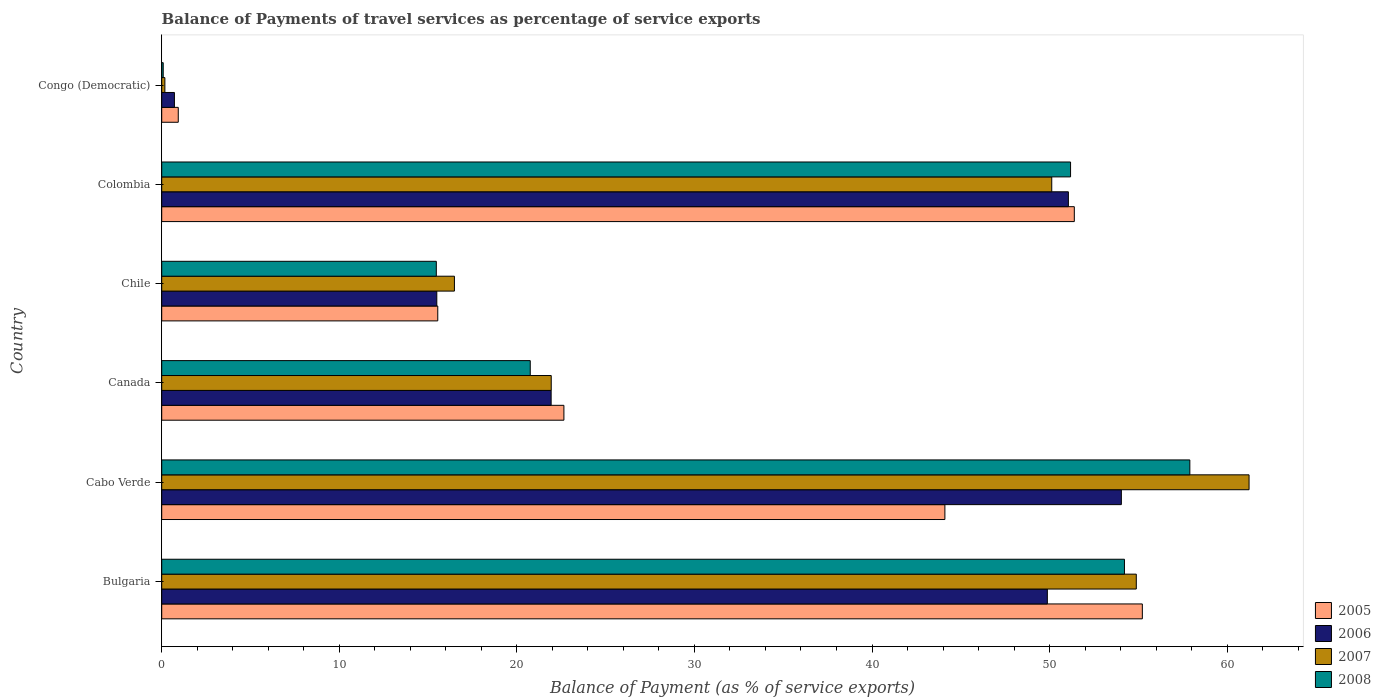Are the number of bars on each tick of the Y-axis equal?
Keep it short and to the point. Yes. How many bars are there on the 5th tick from the top?
Your response must be concise. 4. What is the label of the 4th group of bars from the top?
Ensure brevity in your answer.  Canada. What is the balance of payments of travel services in 2008 in Bulgaria?
Ensure brevity in your answer.  54.22. Across all countries, what is the maximum balance of payments of travel services in 2005?
Give a very brief answer. 55.22. Across all countries, what is the minimum balance of payments of travel services in 2006?
Your response must be concise. 0.72. In which country was the balance of payments of travel services in 2006 maximum?
Your answer should be compact. Cabo Verde. In which country was the balance of payments of travel services in 2007 minimum?
Provide a short and direct response. Congo (Democratic). What is the total balance of payments of travel services in 2008 in the graph?
Give a very brief answer. 199.6. What is the difference between the balance of payments of travel services in 2008 in Bulgaria and that in Cabo Verde?
Your response must be concise. -3.68. What is the difference between the balance of payments of travel services in 2005 in Chile and the balance of payments of travel services in 2007 in Bulgaria?
Your answer should be compact. -39.34. What is the average balance of payments of travel services in 2007 per country?
Provide a succinct answer. 34.14. What is the difference between the balance of payments of travel services in 2005 and balance of payments of travel services in 2008 in Colombia?
Your answer should be very brief. 0.21. What is the ratio of the balance of payments of travel services in 2006 in Canada to that in Colombia?
Ensure brevity in your answer.  0.43. Is the balance of payments of travel services in 2007 in Chile less than that in Congo (Democratic)?
Provide a short and direct response. No. What is the difference between the highest and the second highest balance of payments of travel services in 2007?
Provide a short and direct response. 6.35. What is the difference between the highest and the lowest balance of payments of travel services in 2007?
Provide a short and direct response. 61.05. In how many countries, is the balance of payments of travel services in 2007 greater than the average balance of payments of travel services in 2007 taken over all countries?
Keep it short and to the point. 3. Is the sum of the balance of payments of travel services in 2008 in Cabo Verde and Congo (Democratic) greater than the maximum balance of payments of travel services in 2006 across all countries?
Provide a succinct answer. Yes. What does the 4th bar from the top in Bulgaria represents?
Provide a short and direct response. 2005. What does the 1st bar from the bottom in Cabo Verde represents?
Your answer should be compact. 2005. Are all the bars in the graph horizontal?
Offer a very short reply. Yes. Does the graph contain grids?
Your answer should be compact. No. Where does the legend appear in the graph?
Your answer should be very brief. Bottom right. What is the title of the graph?
Ensure brevity in your answer.  Balance of Payments of travel services as percentage of service exports. What is the label or title of the X-axis?
Keep it short and to the point. Balance of Payment (as % of service exports). What is the label or title of the Y-axis?
Provide a short and direct response. Country. What is the Balance of Payment (as % of service exports) in 2005 in Bulgaria?
Keep it short and to the point. 55.22. What is the Balance of Payment (as % of service exports) in 2006 in Bulgaria?
Ensure brevity in your answer.  49.87. What is the Balance of Payment (as % of service exports) in 2007 in Bulgaria?
Ensure brevity in your answer.  54.88. What is the Balance of Payment (as % of service exports) of 2008 in Bulgaria?
Ensure brevity in your answer.  54.22. What is the Balance of Payment (as % of service exports) of 2005 in Cabo Verde?
Your answer should be very brief. 44.1. What is the Balance of Payment (as % of service exports) in 2006 in Cabo Verde?
Provide a succinct answer. 54.04. What is the Balance of Payment (as % of service exports) of 2007 in Cabo Verde?
Your response must be concise. 61.23. What is the Balance of Payment (as % of service exports) in 2008 in Cabo Verde?
Your answer should be compact. 57.9. What is the Balance of Payment (as % of service exports) in 2005 in Canada?
Keep it short and to the point. 22.65. What is the Balance of Payment (as % of service exports) of 2006 in Canada?
Keep it short and to the point. 21.93. What is the Balance of Payment (as % of service exports) in 2007 in Canada?
Keep it short and to the point. 21.94. What is the Balance of Payment (as % of service exports) in 2008 in Canada?
Offer a terse response. 20.75. What is the Balance of Payment (as % of service exports) in 2005 in Chile?
Offer a very short reply. 15.55. What is the Balance of Payment (as % of service exports) in 2006 in Chile?
Provide a succinct answer. 15.49. What is the Balance of Payment (as % of service exports) in 2007 in Chile?
Your answer should be compact. 16.48. What is the Balance of Payment (as % of service exports) in 2008 in Chile?
Keep it short and to the point. 15.46. What is the Balance of Payment (as % of service exports) of 2005 in Colombia?
Make the answer very short. 51.39. What is the Balance of Payment (as % of service exports) in 2006 in Colombia?
Your answer should be compact. 51.06. What is the Balance of Payment (as % of service exports) in 2007 in Colombia?
Your answer should be very brief. 50.12. What is the Balance of Payment (as % of service exports) in 2008 in Colombia?
Give a very brief answer. 51.18. What is the Balance of Payment (as % of service exports) in 2005 in Congo (Democratic)?
Make the answer very short. 0.93. What is the Balance of Payment (as % of service exports) in 2006 in Congo (Democratic)?
Your answer should be compact. 0.72. What is the Balance of Payment (as % of service exports) in 2007 in Congo (Democratic)?
Provide a short and direct response. 0.18. What is the Balance of Payment (as % of service exports) of 2008 in Congo (Democratic)?
Your response must be concise. 0.08. Across all countries, what is the maximum Balance of Payment (as % of service exports) of 2005?
Make the answer very short. 55.22. Across all countries, what is the maximum Balance of Payment (as % of service exports) in 2006?
Offer a very short reply. 54.04. Across all countries, what is the maximum Balance of Payment (as % of service exports) of 2007?
Provide a succinct answer. 61.23. Across all countries, what is the maximum Balance of Payment (as % of service exports) in 2008?
Provide a succinct answer. 57.9. Across all countries, what is the minimum Balance of Payment (as % of service exports) in 2005?
Your answer should be very brief. 0.93. Across all countries, what is the minimum Balance of Payment (as % of service exports) in 2006?
Provide a succinct answer. 0.72. Across all countries, what is the minimum Balance of Payment (as % of service exports) of 2007?
Your response must be concise. 0.18. Across all countries, what is the minimum Balance of Payment (as % of service exports) in 2008?
Make the answer very short. 0.08. What is the total Balance of Payment (as % of service exports) of 2005 in the graph?
Make the answer very short. 189.84. What is the total Balance of Payment (as % of service exports) in 2006 in the graph?
Provide a short and direct response. 193.11. What is the total Balance of Payment (as % of service exports) in 2007 in the graph?
Provide a short and direct response. 204.83. What is the total Balance of Payment (as % of service exports) in 2008 in the graph?
Ensure brevity in your answer.  199.6. What is the difference between the Balance of Payment (as % of service exports) in 2005 in Bulgaria and that in Cabo Verde?
Give a very brief answer. 11.12. What is the difference between the Balance of Payment (as % of service exports) in 2006 in Bulgaria and that in Cabo Verde?
Keep it short and to the point. -4.17. What is the difference between the Balance of Payment (as % of service exports) in 2007 in Bulgaria and that in Cabo Verde?
Provide a succinct answer. -6.35. What is the difference between the Balance of Payment (as % of service exports) of 2008 in Bulgaria and that in Cabo Verde?
Provide a short and direct response. -3.68. What is the difference between the Balance of Payment (as % of service exports) in 2005 in Bulgaria and that in Canada?
Provide a short and direct response. 32.57. What is the difference between the Balance of Payment (as % of service exports) of 2006 in Bulgaria and that in Canada?
Give a very brief answer. 27.94. What is the difference between the Balance of Payment (as % of service exports) of 2007 in Bulgaria and that in Canada?
Keep it short and to the point. 32.95. What is the difference between the Balance of Payment (as % of service exports) of 2008 in Bulgaria and that in Canada?
Offer a terse response. 33.46. What is the difference between the Balance of Payment (as % of service exports) in 2005 in Bulgaria and that in Chile?
Make the answer very short. 39.68. What is the difference between the Balance of Payment (as % of service exports) in 2006 in Bulgaria and that in Chile?
Your answer should be compact. 34.38. What is the difference between the Balance of Payment (as % of service exports) of 2007 in Bulgaria and that in Chile?
Provide a short and direct response. 38.4. What is the difference between the Balance of Payment (as % of service exports) in 2008 in Bulgaria and that in Chile?
Offer a terse response. 38.75. What is the difference between the Balance of Payment (as % of service exports) in 2005 in Bulgaria and that in Colombia?
Your answer should be very brief. 3.83. What is the difference between the Balance of Payment (as % of service exports) in 2006 in Bulgaria and that in Colombia?
Provide a short and direct response. -1.18. What is the difference between the Balance of Payment (as % of service exports) of 2007 in Bulgaria and that in Colombia?
Provide a short and direct response. 4.76. What is the difference between the Balance of Payment (as % of service exports) of 2008 in Bulgaria and that in Colombia?
Your answer should be compact. 3.03. What is the difference between the Balance of Payment (as % of service exports) in 2005 in Bulgaria and that in Congo (Democratic)?
Keep it short and to the point. 54.29. What is the difference between the Balance of Payment (as % of service exports) in 2006 in Bulgaria and that in Congo (Democratic)?
Give a very brief answer. 49.16. What is the difference between the Balance of Payment (as % of service exports) in 2007 in Bulgaria and that in Congo (Democratic)?
Provide a succinct answer. 54.7. What is the difference between the Balance of Payment (as % of service exports) of 2008 in Bulgaria and that in Congo (Democratic)?
Keep it short and to the point. 54.13. What is the difference between the Balance of Payment (as % of service exports) in 2005 in Cabo Verde and that in Canada?
Provide a succinct answer. 21.45. What is the difference between the Balance of Payment (as % of service exports) in 2006 in Cabo Verde and that in Canada?
Your response must be concise. 32.11. What is the difference between the Balance of Payment (as % of service exports) of 2007 in Cabo Verde and that in Canada?
Keep it short and to the point. 39.3. What is the difference between the Balance of Payment (as % of service exports) of 2008 in Cabo Verde and that in Canada?
Your response must be concise. 37.14. What is the difference between the Balance of Payment (as % of service exports) of 2005 in Cabo Verde and that in Chile?
Your response must be concise. 28.56. What is the difference between the Balance of Payment (as % of service exports) in 2006 in Cabo Verde and that in Chile?
Your answer should be compact. 38.55. What is the difference between the Balance of Payment (as % of service exports) of 2007 in Cabo Verde and that in Chile?
Offer a very short reply. 44.75. What is the difference between the Balance of Payment (as % of service exports) of 2008 in Cabo Verde and that in Chile?
Ensure brevity in your answer.  42.43. What is the difference between the Balance of Payment (as % of service exports) of 2005 in Cabo Verde and that in Colombia?
Make the answer very short. -7.29. What is the difference between the Balance of Payment (as % of service exports) in 2006 in Cabo Verde and that in Colombia?
Keep it short and to the point. 2.98. What is the difference between the Balance of Payment (as % of service exports) of 2007 in Cabo Verde and that in Colombia?
Give a very brief answer. 11.11. What is the difference between the Balance of Payment (as % of service exports) in 2008 in Cabo Verde and that in Colombia?
Your answer should be very brief. 6.72. What is the difference between the Balance of Payment (as % of service exports) in 2005 in Cabo Verde and that in Congo (Democratic)?
Your response must be concise. 43.17. What is the difference between the Balance of Payment (as % of service exports) of 2006 in Cabo Verde and that in Congo (Democratic)?
Your answer should be compact. 53.33. What is the difference between the Balance of Payment (as % of service exports) in 2007 in Cabo Verde and that in Congo (Democratic)?
Offer a very short reply. 61.05. What is the difference between the Balance of Payment (as % of service exports) of 2008 in Cabo Verde and that in Congo (Democratic)?
Your answer should be compact. 57.81. What is the difference between the Balance of Payment (as % of service exports) in 2005 in Canada and that in Chile?
Offer a very short reply. 7.1. What is the difference between the Balance of Payment (as % of service exports) in 2006 in Canada and that in Chile?
Keep it short and to the point. 6.44. What is the difference between the Balance of Payment (as % of service exports) in 2007 in Canada and that in Chile?
Provide a succinct answer. 5.45. What is the difference between the Balance of Payment (as % of service exports) of 2008 in Canada and that in Chile?
Make the answer very short. 5.29. What is the difference between the Balance of Payment (as % of service exports) in 2005 in Canada and that in Colombia?
Offer a terse response. -28.74. What is the difference between the Balance of Payment (as % of service exports) in 2006 in Canada and that in Colombia?
Keep it short and to the point. -29.13. What is the difference between the Balance of Payment (as % of service exports) in 2007 in Canada and that in Colombia?
Provide a succinct answer. -28.19. What is the difference between the Balance of Payment (as % of service exports) of 2008 in Canada and that in Colombia?
Provide a short and direct response. -30.43. What is the difference between the Balance of Payment (as % of service exports) of 2005 in Canada and that in Congo (Democratic)?
Provide a short and direct response. 21.72. What is the difference between the Balance of Payment (as % of service exports) in 2006 in Canada and that in Congo (Democratic)?
Make the answer very short. 21.21. What is the difference between the Balance of Payment (as % of service exports) of 2007 in Canada and that in Congo (Democratic)?
Make the answer very short. 21.76. What is the difference between the Balance of Payment (as % of service exports) of 2008 in Canada and that in Congo (Democratic)?
Give a very brief answer. 20.67. What is the difference between the Balance of Payment (as % of service exports) of 2005 in Chile and that in Colombia?
Provide a succinct answer. -35.85. What is the difference between the Balance of Payment (as % of service exports) of 2006 in Chile and that in Colombia?
Ensure brevity in your answer.  -35.57. What is the difference between the Balance of Payment (as % of service exports) in 2007 in Chile and that in Colombia?
Keep it short and to the point. -33.64. What is the difference between the Balance of Payment (as % of service exports) of 2008 in Chile and that in Colombia?
Ensure brevity in your answer.  -35.72. What is the difference between the Balance of Payment (as % of service exports) in 2005 in Chile and that in Congo (Democratic)?
Offer a very short reply. 14.61. What is the difference between the Balance of Payment (as % of service exports) of 2006 in Chile and that in Congo (Democratic)?
Provide a succinct answer. 14.78. What is the difference between the Balance of Payment (as % of service exports) in 2007 in Chile and that in Congo (Democratic)?
Provide a succinct answer. 16.31. What is the difference between the Balance of Payment (as % of service exports) in 2008 in Chile and that in Congo (Democratic)?
Ensure brevity in your answer.  15.38. What is the difference between the Balance of Payment (as % of service exports) of 2005 in Colombia and that in Congo (Democratic)?
Give a very brief answer. 50.46. What is the difference between the Balance of Payment (as % of service exports) of 2006 in Colombia and that in Congo (Democratic)?
Provide a succinct answer. 50.34. What is the difference between the Balance of Payment (as % of service exports) in 2007 in Colombia and that in Congo (Democratic)?
Your answer should be very brief. 49.94. What is the difference between the Balance of Payment (as % of service exports) of 2008 in Colombia and that in Congo (Democratic)?
Keep it short and to the point. 51.1. What is the difference between the Balance of Payment (as % of service exports) of 2005 in Bulgaria and the Balance of Payment (as % of service exports) of 2006 in Cabo Verde?
Your response must be concise. 1.18. What is the difference between the Balance of Payment (as % of service exports) of 2005 in Bulgaria and the Balance of Payment (as % of service exports) of 2007 in Cabo Verde?
Offer a very short reply. -6.01. What is the difference between the Balance of Payment (as % of service exports) in 2005 in Bulgaria and the Balance of Payment (as % of service exports) in 2008 in Cabo Verde?
Keep it short and to the point. -2.67. What is the difference between the Balance of Payment (as % of service exports) in 2006 in Bulgaria and the Balance of Payment (as % of service exports) in 2007 in Cabo Verde?
Provide a succinct answer. -11.36. What is the difference between the Balance of Payment (as % of service exports) in 2006 in Bulgaria and the Balance of Payment (as % of service exports) in 2008 in Cabo Verde?
Provide a succinct answer. -8.02. What is the difference between the Balance of Payment (as % of service exports) in 2007 in Bulgaria and the Balance of Payment (as % of service exports) in 2008 in Cabo Verde?
Offer a terse response. -3.02. What is the difference between the Balance of Payment (as % of service exports) in 2005 in Bulgaria and the Balance of Payment (as % of service exports) in 2006 in Canada?
Your response must be concise. 33.29. What is the difference between the Balance of Payment (as % of service exports) in 2005 in Bulgaria and the Balance of Payment (as % of service exports) in 2007 in Canada?
Provide a short and direct response. 33.29. What is the difference between the Balance of Payment (as % of service exports) in 2005 in Bulgaria and the Balance of Payment (as % of service exports) in 2008 in Canada?
Give a very brief answer. 34.47. What is the difference between the Balance of Payment (as % of service exports) of 2006 in Bulgaria and the Balance of Payment (as % of service exports) of 2007 in Canada?
Your response must be concise. 27.94. What is the difference between the Balance of Payment (as % of service exports) of 2006 in Bulgaria and the Balance of Payment (as % of service exports) of 2008 in Canada?
Offer a very short reply. 29.12. What is the difference between the Balance of Payment (as % of service exports) in 2007 in Bulgaria and the Balance of Payment (as % of service exports) in 2008 in Canada?
Provide a short and direct response. 34.13. What is the difference between the Balance of Payment (as % of service exports) of 2005 in Bulgaria and the Balance of Payment (as % of service exports) of 2006 in Chile?
Make the answer very short. 39.73. What is the difference between the Balance of Payment (as % of service exports) in 2005 in Bulgaria and the Balance of Payment (as % of service exports) in 2007 in Chile?
Ensure brevity in your answer.  38.74. What is the difference between the Balance of Payment (as % of service exports) in 2005 in Bulgaria and the Balance of Payment (as % of service exports) in 2008 in Chile?
Your response must be concise. 39.76. What is the difference between the Balance of Payment (as % of service exports) in 2006 in Bulgaria and the Balance of Payment (as % of service exports) in 2007 in Chile?
Ensure brevity in your answer.  33.39. What is the difference between the Balance of Payment (as % of service exports) in 2006 in Bulgaria and the Balance of Payment (as % of service exports) in 2008 in Chile?
Give a very brief answer. 34.41. What is the difference between the Balance of Payment (as % of service exports) in 2007 in Bulgaria and the Balance of Payment (as % of service exports) in 2008 in Chile?
Keep it short and to the point. 39.42. What is the difference between the Balance of Payment (as % of service exports) of 2005 in Bulgaria and the Balance of Payment (as % of service exports) of 2006 in Colombia?
Your answer should be compact. 4.17. What is the difference between the Balance of Payment (as % of service exports) of 2005 in Bulgaria and the Balance of Payment (as % of service exports) of 2007 in Colombia?
Offer a very short reply. 5.1. What is the difference between the Balance of Payment (as % of service exports) in 2005 in Bulgaria and the Balance of Payment (as % of service exports) in 2008 in Colombia?
Keep it short and to the point. 4.04. What is the difference between the Balance of Payment (as % of service exports) of 2006 in Bulgaria and the Balance of Payment (as % of service exports) of 2007 in Colombia?
Offer a very short reply. -0.25. What is the difference between the Balance of Payment (as % of service exports) in 2006 in Bulgaria and the Balance of Payment (as % of service exports) in 2008 in Colombia?
Your answer should be very brief. -1.31. What is the difference between the Balance of Payment (as % of service exports) in 2007 in Bulgaria and the Balance of Payment (as % of service exports) in 2008 in Colombia?
Keep it short and to the point. 3.7. What is the difference between the Balance of Payment (as % of service exports) in 2005 in Bulgaria and the Balance of Payment (as % of service exports) in 2006 in Congo (Democratic)?
Provide a short and direct response. 54.51. What is the difference between the Balance of Payment (as % of service exports) of 2005 in Bulgaria and the Balance of Payment (as % of service exports) of 2007 in Congo (Democratic)?
Your answer should be very brief. 55.05. What is the difference between the Balance of Payment (as % of service exports) of 2005 in Bulgaria and the Balance of Payment (as % of service exports) of 2008 in Congo (Democratic)?
Your response must be concise. 55.14. What is the difference between the Balance of Payment (as % of service exports) of 2006 in Bulgaria and the Balance of Payment (as % of service exports) of 2007 in Congo (Democratic)?
Ensure brevity in your answer.  49.7. What is the difference between the Balance of Payment (as % of service exports) in 2006 in Bulgaria and the Balance of Payment (as % of service exports) in 2008 in Congo (Democratic)?
Your answer should be compact. 49.79. What is the difference between the Balance of Payment (as % of service exports) in 2007 in Bulgaria and the Balance of Payment (as % of service exports) in 2008 in Congo (Democratic)?
Make the answer very short. 54.8. What is the difference between the Balance of Payment (as % of service exports) of 2005 in Cabo Verde and the Balance of Payment (as % of service exports) of 2006 in Canada?
Your answer should be very brief. 22.17. What is the difference between the Balance of Payment (as % of service exports) of 2005 in Cabo Verde and the Balance of Payment (as % of service exports) of 2007 in Canada?
Your response must be concise. 22.17. What is the difference between the Balance of Payment (as % of service exports) in 2005 in Cabo Verde and the Balance of Payment (as % of service exports) in 2008 in Canada?
Offer a very short reply. 23.35. What is the difference between the Balance of Payment (as % of service exports) of 2006 in Cabo Verde and the Balance of Payment (as % of service exports) of 2007 in Canada?
Your answer should be very brief. 32.11. What is the difference between the Balance of Payment (as % of service exports) in 2006 in Cabo Verde and the Balance of Payment (as % of service exports) in 2008 in Canada?
Provide a succinct answer. 33.29. What is the difference between the Balance of Payment (as % of service exports) of 2007 in Cabo Verde and the Balance of Payment (as % of service exports) of 2008 in Canada?
Your answer should be compact. 40.48. What is the difference between the Balance of Payment (as % of service exports) in 2005 in Cabo Verde and the Balance of Payment (as % of service exports) in 2006 in Chile?
Offer a terse response. 28.61. What is the difference between the Balance of Payment (as % of service exports) of 2005 in Cabo Verde and the Balance of Payment (as % of service exports) of 2007 in Chile?
Your answer should be very brief. 27.62. What is the difference between the Balance of Payment (as % of service exports) in 2005 in Cabo Verde and the Balance of Payment (as % of service exports) in 2008 in Chile?
Give a very brief answer. 28.64. What is the difference between the Balance of Payment (as % of service exports) of 2006 in Cabo Verde and the Balance of Payment (as % of service exports) of 2007 in Chile?
Make the answer very short. 37.56. What is the difference between the Balance of Payment (as % of service exports) in 2006 in Cabo Verde and the Balance of Payment (as % of service exports) in 2008 in Chile?
Keep it short and to the point. 38.58. What is the difference between the Balance of Payment (as % of service exports) in 2007 in Cabo Verde and the Balance of Payment (as % of service exports) in 2008 in Chile?
Provide a succinct answer. 45.77. What is the difference between the Balance of Payment (as % of service exports) in 2005 in Cabo Verde and the Balance of Payment (as % of service exports) in 2006 in Colombia?
Make the answer very short. -6.95. What is the difference between the Balance of Payment (as % of service exports) of 2005 in Cabo Verde and the Balance of Payment (as % of service exports) of 2007 in Colombia?
Ensure brevity in your answer.  -6.02. What is the difference between the Balance of Payment (as % of service exports) in 2005 in Cabo Verde and the Balance of Payment (as % of service exports) in 2008 in Colombia?
Keep it short and to the point. -7.08. What is the difference between the Balance of Payment (as % of service exports) in 2006 in Cabo Verde and the Balance of Payment (as % of service exports) in 2007 in Colombia?
Your answer should be very brief. 3.92. What is the difference between the Balance of Payment (as % of service exports) in 2006 in Cabo Verde and the Balance of Payment (as % of service exports) in 2008 in Colombia?
Keep it short and to the point. 2.86. What is the difference between the Balance of Payment (as % of service exports) in 2007 in Cabo Verde and the Balance of Payment (as % of service exports) in 2008 in Colombia?
Provide a succinct answer. 10.05. What is the difference between the Balance of Payment (as % of service exports) in 2005 in Cabo Verde and the Balance of Payment (as % of service exports) in 2006 in Congo (Democratic)?
Provide a short and direct response. 43.39. What is the difference between the Balance of Payment (as % of service exports) of 2005 in Cabo Verde and the Balance of Payment (as % of service exports) of 2007 in Congo (Democratic)?
Your answer should be very brief. 43.92. What is the difference between the Balance of Payment (as % of service exports) of 2005 in Cabo Verde and the Balance of Payment (as % of service exports) of 2008 in Congo (Democratic)?
Your answer should be compact. 44.02. What is the difference between the Balance of Payment (as % of service exports) in 2006 in Cabo Verde and the Balance of Payment (as % of service exports) in 2007 in Congo (Democratic)?
Keep it short and to the point. 53.86. What is the difference between the Balance of Payment (as % of service exports) in 2006 in Cabo Verde and the Balance of Payment (as % of service exports) in 2008 in Congo (Democratic)?
Provide a succinct answer. 53.96. What is the difference between the Balance of Payment (as % of service exports) in 2007 in Cabo Verde and the Balance of Payment (as % of service exports) in 2008 in Congo (Democratic)?
Provide a short and direct response. 61.15. What is the difference between the Balance of Payment (as % of service exports) of 2005 in Canada and the Balance of Payment (as % of service exports) of 2006 in Chile?
Your response must be concise. 7.16. What is the difference between the Balance of Payment (as % of service exports) in 2005 in Canada and the Balance of Payment (as % of service exports) in 2007 in Chile?
Make the answer very short. 6.16. What is the difference between the Balance of Payment (as % of service exports) of 2005 in Canada and the Balance of Payment (as % of service exports) of 2008 in Chile?
Provide a succinct answer. 7.19. What is the difference between the Balance of Payment (as % of service exports) of 2006 in Canada and the Balance of Payment (as % of service exports) of 2007 in Chile?
Provide a succinct answer. 5.45. What is the difference between the Balance of Payment (as % of service exports) in 2006 in Canada and the Balance of Payment (as % of service exports) in 2008 in Chile?
Make the answer very short. 6.47. What is the difference between the Balance of Payment (as % of service exports) in 2007 in Canada and the Balance of Payment (as % of service exports) in 2008 in Chile?
Make the answer very short. 6.47. What is the difference between the Balance of Payment (as % of service exports) of 2005 in Canada and the Balance of Payment (as % of service exports) of 2006 in Colombia?
Your answer should be very brief. -28.41. What is the difference between the Balance of Payment (as % of service exports) of 2005 in Canada and the Balance of Payment (as % of service exports) of 2007 in Colombia?
Provide a short and direct response. -27.47. What is the difference between the Balance of Payment (as % of service exports) of 2005 in Canada and the Balance of Payment (as % of service exports) of 2008 in Colombia?
Offer a very short reply. -28.53. What is the difference between the Balance of Payment (as % of service exports) in 2006 in Canada and the Balance of Payment (as % of service exports) in 2007 in Colombia?
Keep it short and to the point. -28.19. What is the difference between the Balance of Payment (as % of service exports) of 2006 in Canada and the Balance of Payment (as % of service exports) of 2008 in Colombia?
Your answer should be very brief. -29.25. What is the difference between the Balance of Payment (as % of service exports) of 2007 in Canada and the Balance of Payment (as % of service exports) of 2008 in Colombia?
Make the answer very short. -29.25. What is the difference between the Balance of Payment (as % of service exports) of 2005 in Canada and the Balance of Payment (as % of service exports) of 2006 in Congo (Democratic)?
Offer a terse response. 21.93. What is the difference between the Balance of Payment (as % of service exports) in 2005 in Canada and the Balance of Payment (as % of service exports) in 2007 in Congo (Democratic)?
Offer a terse response. 22.47. What is the difference between the Balance of Payment (as % of service exports) of 2005 in Canada and the Balance of Payment (as % of service exports) of 2008 in Congo (Democratic)?
Offer a very short reply. 22.56. What is the difference between the Balance of Payment (as % of service exports) of 2006 in Canada and the Balance of Payment (as % of service exports) of 2007 in Congo (Democratic)?
Offer a terse response. 21.75. What is the difference between the Balance of Payment (as % of service exports) of 2006 in Canada and the Balance of Payment (as % of service exports) of 2008 in Congo (Democratic)?
Offer a terse response. 21.85. What is the difference between the Balance of Payment (as % of service exports) in 2007 in Canada and the Balance of Payment (as % of service exports) in 2008 in Congo (Democratic)?
Your response must be concise. 21.85. What is the difference between the Balance of Payment (as % of service exports) of 2005 in Chile and the Balance of Payment (as % of service exports) of 2006 in Colombia?
Give a very brief answer. -35.51. What is the difference between the Balance of Payment (as % of service exports) of 2005 in Chile and the Balance of Payment (as % of service exports) of 2007 in Colombia?
Provide a succinct answer. -34.58. What is the difference between the Balance of Payment (as % of service exports) in 2005 in Chile and the Balance of Payment (as % of service exports) in 2008 in Colombia?
Your answer should be compact. -35.64. What is the difference between the Balance of Payment (as % of service exports) of 2006 in Chile and the Balance of Payment (as % of service exports) of 2007 in Colombia?
Offer a very short reply. -34.63. What is the difference between the Balance of Payment (as % of service exports) of 2006 in Chile and the Balance of Payment (as % of service exports) of 2008 in Colombia?
Give a very brief answer. -35.69. What is the difference between the Balance of Payment (as % of service exports) in 2007 in Chile and the Balance of Payment (as % of service exports) in 2008 in Colombia?
Provide a succinct answer. -34.7. What is the difference between the Balance of Payment (as % of service exports) in 2005 in Chile and the Balance of Payment (as % of service exports) in 2006 in Congo (Democratic)?
Your response must be concise. 14.83. What is the difference between the Balance of Payment (as % of service exports) in 2005 in Chile and the Balance of Payment (as % of service exports) in 2007 in Congo (Democratic)?
Keep it short and to the point. 15.37. What is the difference between the Balance of Payment (as % of service exports) of 2005 in Chile and the Balance of Payment (as % of service exports) of 2008 in Congo (Democratic)?
Give a very brief answer. 15.46. What is the difference between the Balance of Payment (as % of service exports) in 2006 in Chile and the Balance of Payment (as % of service exports) in 2007 in Congo (Democratic)?
Offer a very short reply. 15.31. What is the difference between the Balance of Payment (as % of service exports) in 2006 in Chile and the Balance of Payment (as % of service exports) in 2008 in Congo (Democratic)?
Provide a short and direct response. 15.41. What is the difference between the Balance of Payment (as % of service exports) in 2007 in Chile and the Balance of Payment (as % of service exports) in 2008 in Congo (Democratic)?
Offer a very short reply. 16.4. What is the difference between the Balance of Payment (as % of service exports) of 2005 in Colombia and the Balance of Payment (as % of service exports) of 2006 in Congo (Democratic)?
Ensure brevity in your answer.  50.68. What is the difference between the Balance of Payment (as % of service exports) of 2005 in Colombia and the Balance of Payment (as % of service exports) of 2007 in Congo (Democratic)?
Your answer should be very brief. 51.21. What is the difference between the Balance of Payment (as % of service exports) in 2005 in Colombia and the Balance of Payment (as % of service exports) in 2008 in Congo (Democratic)?
Keep it short and to the point. 51.31. What is the difference between the Balance of Payment (as % of service exports) of 2006 in Colombia and the Balance of Payment (as % of service exports) of 2007 in Congo (Democratic)?
Your answer should be very brief. 50.88. What is the difference between the Balance of Payment (as % of service exports) of 2006 in Colombia and the Balance of Payment (as % of service exports) of 2008 in Congo (Democratic)?
Provide a short and direct response. 50.97. What is the difference between the Balance of Payment (as % of service exports) in 2007 in Colombia and the Balance of Payment (as % of service exports) in 2008 in Congo (Democratic)?
Your response must be concise. 50.04. What is the average Balance of Payment (as % of service exports) of 2005 per country?
Make the answer very short. 31.64. What is the average Balance of Payment (as % of service exports) of 2006 per country?
Ensure brevity in your answer.  32.19. What is the average Balance of Payment (as % of service exports) in 2007 per country?
Your response must be concise. 34.14. What is the average Balance of Payment (as % of service exports) of 2008 per country?
Provide a succinct answer. 33.27. What is the difference between the Balance of Payment (as % of service exports) of 2005 and Balance of Payment (as % of service exports) of 2006 in Bulgaria?
Ensure brevity in your answer.  5.35. What is the difference between the Balance of Payment (as % of service exports) of 2005 and Balance of Payment (as % of service exports) of 2007 in Bulgaria?
Your answer should be compact. 0.34. What is the difference between the Balance of Payment (as % of service exports) in 2005 and Balance of Payment (as % of service exports) in 2008 in Bulgaria?
Make the answer very short. 1.01. What is the difference between the Balance of Payment (as % of service exports) of 2006 and Balance of Payment (as % of service exports) of 2007 in Bulgaria?
Offer a very short reply. -5.01. What is the difference between the Balance of Payment (as % of service exports) of 2006 and Balance of Payment (as % of service exports) of 2008 in Bulgaria?
Keep it short and to the point. -4.34. What is the difference between the Balance of Payment (as % of service exports) of 2007 and Balance of Payment (as % of service exports) of 2008 in Bulgaria?
Ensure brevity in your answer.  0.67. What is the difference between the Balance of Payment (as % of service exports) of 2005 and Balance of Payment (as % of service exports) of 2006 in Cabo Verde?
Give a very brief answer. -9.94. What is the difference between the Balance of Payment (as % of service exports) of 2005 and Balance of Payment (as % of service exports) of 2007 in Cabo Verde?
Make the answer very short. -17.13. What is the difference between the Balance of Payment (as % of service exports) in 2005 and Balance of Payment (as % of service exports) in 2008 in Cabo Verde?
Ensure brevity in your answer.  -13.79. What is the difference between the Balance of Payment (as % of service exports) in 2006 and Balance of Payment (as % of service exports) in 2007 in Cabo Verde?
Give a very brief answer. -7.19. What is the difference between the Balance of Payment (as % of service exports) in 2006 and Balance of Payment (as % of service exports) in 2008 in Cabo Verde?
Provide a short and direct response. -3.86. What is the difference between the Balance of Payment (as % of service exports) of 2007 and Balance of Payment (as % of service exports) of 2008 in Cabo Verde?
Make the answer very short. 3.33. What is the difference between the Balance of Payment (as % of service exports) in 2005 and Balance of Payment (as % of service exports) in 2006 in Canada?
Your answer should be very brief. 0.72. What is the difference between the Balance of Payment (as % of service exports) in 2005 and Balance of Payment (as % of service exports) in 2007 in Canada?
Ensure brevity in your answer.  0.71. What is the difference between the Balance of Payment (as % of service exports) of 2005 and Balance of Payment (as % of service exports) of 2008 in Canada?
Ensure brevity in your answer.  1.9. What is the difference between the Balance of Payment (as % of service exports) of 2006 and Balance of Payment (as % of service exports) of 2007 in Canada?
Your answer should be very brief. -0.01. What is the difference between the Balance of Payment (as % of service exports) of 2006 and Balance of Payment (as % of service exports) of 2008 in Canada?
Provide a short and direct response. 1.18. What is the difference between the Balance of Payment (as % of service exports) of 2007 and Balance of Payment (as % of service exports) of 2008 in Canada?
Provide a succinct answer. 1.18. What is the difference between the Balance of Payment (as % of service exports) of 2005 and Balance of Payment (as % of service exports) of 2006 in Chile?
Provide a succinct answer. 0.05. What is the difference between the Balance of Payment (as % of service exports) in 2005 and Balance of Payment (as % of service exports) in 2007 in Chile?
Make the answer very short. -0.94. What is the difference between the Balance of Payment (as % of service exports) of 2005 and Balance of Payment (as % of service exports) of 2008 in Chile?
Give a very brief answer. 0.08. What is the difference between the Balance of Payment (as % of service exports) of 2006 and Balance of Payment (as % of service exports) of 2007 in Chile?
Give a very brief answer. -0.99. What is the difference between the Balance of Payment (as % of service exports) of 2006 and Balance of Payment (as % of service exports) of 2008 in Chile?
Offer a very short reply. 0.03. What is the difference between the Balance of Payment (as % of service exports) of 2007 and Balance of Payment (as % of service exports) of 2008 in Chile?
Your answer should be compact. 1.02. What is the difference between the Balance of Payment (as % of service exports) in 2005 and Balance of Payment (as % of service exports) in 2006 in Colombia?
Your response must be concise. 0.33. What is the difference between the Balance of Payment (as % of service exports) in 2005 and Balance of Payment (as % of service exports) in 2007 in Colombia?
Make the answer very short. 1.27. What is the difference between the Balance of Payment (as % of service exports) in 2005 and Balance of Payment (as % of service exports) in 2008 in Colombia?
Provide a short and direct response. 0.21. What is the difference between the Balance of Payment (as % of service exports) of 2006 and Balance of Payment (as % of service exports) of 2007 in Colombia?
Keep it short and to the point. 0.94. What is the difference between the Balance of Payment (as % of service exports) in 2006 and Balance of Payment (as % of service exports) in 2008 in Colombia?
Your response must be concise. -0.12. What is the difference between the Balance of Payment (as % of service exports) in 2007 and Balance of Payment (as % of service exports) in 2008 in Colombia?
Offer a very short reply. -1.06. What is the difference between the Balance of Payment (as % of service exports) of 2005 and Balance of Payment (as % of service exports) of 2006 in Congo (Democratic)?
Your answer should be compact. 0.22. What is the difference between the Balance of Payment (as % of service exports) in 2005 and Balance of Payment (as % of service exports) in 2007 in Congo (Democratic)?
Give a very brief answer. 0.75. What is the difference between the Balance of Payment (as % of service exports) in 2005 and Balance of Payment (as % of service exports) in 2008 in Congo (Democratic)?
Make the answer very short. 0.85. What is the difference between the Balance of Payment (as % of service exports) of 2006 and Balance of Payment (as % of service exports) of 2007 in Congo (Democratic)?
Offer a very short reply. 0.54. What is the difference between the Balance of Payment (as % of service exports) in 2006 and Balance of Payment (as % of service exports) in 2008 in Congo (Democratic)?
Give a very brief answer. 0.63. What is the difference between the Balance of Payment (as % of service exports) in 2007 and Balance of Payment (as % of service exports) in 2008 in Congo (Democratic)?
Ensure brevity in your answer.  0.09. What is the ratio of the Balance of Payment (as % of service exports) of 2005 in Bulgaria to that in Cabo Verde?
Ensure brevity in your answer.  1.25. What is the ratio of the Balance of Payment (as % of service exports) in 2006 in Bulgaria to that in Cabo Verde?
Make the answer very short. 0.92. What is the ratio of the Balance of Payment (as % of service exports) of 2007 in Bulgaria to that in Cabo Verde?
Give a very brief answer. 0.9. What is the ratio of the Balance of Payment (as % of service exports) of 2008 in Bulgaria to that in Cabo Verde?
Keep it short and to the point. 0.94. What is the ratio of the Balance of Payment (as % of service exports) of 2005 in Bulgaria to that in Canada?
Offer a terse response. 2.44. What is the ratio of the Balance of Payment (as % of service exports) in 2006 in Bulgaria to that in Canada?
Make the answer very short. 2.27. What is the ratio of the Balance of Payment (as % of service exports) in 2007 in Bulgaria to that in Canada?
Provide a short and direct response. 2.5. What is the ratio of the Balance of Payment (as % of service exports) of 2008 in Bulgaria to that in Canada?
Make the answer very short. 2.61. What is the ratio of the Balance of Payment (as % of service exports) in 2005 in Bulgaria to that in Chile?
Your answer should be very brief. 3.55. What is the ratio of the Balance of Payment (as % of service exports) of 2006 in Bulgaria to that in Chile?
Give a very brief answer. 3.22. What is the ratio of the Balance of Payment (as % of service exports) of 2007 in Bulgaria to that in Chile?
Offer a very short reply. 3.33. What is the ratio of the Balance of Payment (as % of service exports) of 2008 in Bulgaria to that in Chile?
Your answer should be compact. 3.51. What is the ratio of the Balance of Payment (as % of service exports) of 2005 in Bulgaria to that in Colombia?
Ensure brevity in your answer.  1.07. What is the ratio of the Balance of Payment (as % of service exports) of 2006 in Bulgaria to that in Colombia?
Provide a succinct answer. 0.98. What is the ratio of the Balance of Payment (as % of service exports) of 2007 in Bulgaria to that in Colombia?
Offer a very short reply. 1.09. What is the ratio of the Balance of Payment (as % of service exports) in 2008 in Bulgaria to that in Colombia?
Give a very brief answer. 1.06. What is the ratio of the Balance of Payment (as % of service exports) in 2005 in Bulgaria to that in Congo (Democratic)?
Your answer should be compact. 59.23. What is the ratio of the Balance of Payment (as % of service exports) in 2006 in Bulgaria to that in Congo (Democratic)?
Your response must be concise. 69.65. What is the ratio of the Balance of Payment (as % of service exports) in 2007 in Bulgaria to that in Congo (Democratic)?
Keep it short and to the point. 307.65. What is the ratio of the Balance of Payment (as % of service exports) of 2008 in Bulgaria to that in Congo (Democratic)?
Your response must be concise. 641.44. What is the ratio of the Balance of Payment (as % of service exports) in 2005 in Cabo Verde to that in Canada?
Give a very brief answer. 1.95. What is the ratio of the Balance of Payment (as % of service exports) in 2006 in Cabo Verde to that in Canada?
Keep it short and to the point. 2.46. What is the ratio of the Balance of Payment (as % of service exports) of 2007 in Cabo Verde to that in Canada?
Your answer should be very brief. 2.79. What is the ratio of the Balance of Payment (as % of service exports) in 2008 in Cabo Verde to that in Canada?
Provide a succinct answer. 2.79. What is the ratio of the Balance of Payment (as % of service exports) of 2005 in Cabo Verde to that in Chile?
Your response must be concise. 2.84. What is the ratio of the Balance of Payment (as % of service exports) of 2006 in Cabo Verde to that in Chile?
Make the answer very short. 3.49. What is the ratio of the Balance of Payment (as % of service exports) in 2007 in Cabo Verde to that in Chile?
Provide a succinct answer. 3.71. What is the ratio of the Balance of Payment (as % of service exports) of 2008 in Cabo Verde to that in Chile?
Give a very brief answer. 3.74. What is the ratio of the Balance of Payment (as % of service exports) in 2005 in Cabo Verde to that in Colombia?
Your response must be concise. 0.86. What is the ratio of the Balance of Payment (as % of service exports) in 2006 in Cabo Verde to that in Colombia?
Make the answer very short. 1.06. What is the ratio of the Balance of Payment (as % of service exports) of 2007 in Cabo Verde to that in Colombia?
Provide a succinct answer. 1.22. What is the ratio of the Balance of Payment (as % of service exports) in 2008 in Cabo Verde to that in Colombia?
Provide a short and direct response. 1.13. What is the ratio of the Balance of Payment (as % of service exports) of 2005 in Cabo Verde to that in Congo (Democratic)?
Your answer should be very brief. 47.3. What is the ratio of the Balance of Payment (as % of service exports) of 2006 in Cabo Verde to that in Congo (Democratic)?
Offer a terse response. 75.47. What is the ratio of the Balance of Payment (as % of service exports) of 2007 in Cabo Verde to that in Congo (Democratic)?
Give a very brief answer. 343.25. What is the ratio of the Balance of Payment (as % of service exports) of 2008 in Cabo Verde to that in Congo (Democratic)?
Offer a terse response. 685.01. What is the ratio of the Balance of Payment (as % of service exports) in 2005 in Canada to that in Chile?
Keep it short and to the point. 1.46. What is the ratio of the Balance of Payment (as % of service exports) of 2006 in Canada to that in Chile?
Your answer should be compact. 1.42. What is the ratio of the Balance of Payment (as % of service exports) of 2007 in Canada to that in Chile?
Your response must be concise. 1.33. What is the ratio of the Balance of Payment (as % of service exports) in 2008 in Canada to that in Chile?
Make the answer very short. 1.34. What is the ratio of the Balance of Payment (as % of service exports) of 2005 in Canada to that in Colombia?
Ensure brevity in your answer.  0.44. What is the ratio of the Balance of Payment (as % of service exports) in 2006 in Canada to that in Colombia?
Provide a succinct answer. 0.43. What is the ratio of the Balance of Payment (as % of service exports) in 2007 in Canada to that in Colombia?
Your response must be concise. 0.44. What is the ratio of the Balance of Payment (as % of service exports) of 2008 in Canada to that in Colombia?
Your answer should be very brief. 0.41. What is the ratio of the Balance of Payment (as % of service exports) of 2005 in Canada to that in Congo (Democratic)?
Your answer should be very brief. 24.29. What is the ratio of the Balance of Payment (as % of service exports) in 2006 in Canada to that in Congo (Democratic)?
Make the answer very short. 30.62. What is the ratio of the Balance of Payment (as % of service exports) of 2007 in Canada to that in Congo (Democratic)?
Your answer should be compact. 122.96. What is the ratio of the Balance of Payment (as % of service exports) of 2008 in Canada to that in Congo (Democratic)?
Offer a very short reply. 245.54. What is the ratio of the Balance of Payment (as % of service exports) in 2005 in Chile to that in Colombia?
Give a very brief answer. 0.3. What is the ratio of the Balance of Payment (as % of service exports) in 2006 in Chile to that in Colombia?
Provide a short and direct response. 0.3. What is the ratio of the Balance of Payment (as % of service exports) of 2007 in Chile to that in Colombia?
Your answer should be very brief. 0.33. What is the ratio of the Balance of Payment (as % of service exports) of 2008 in Chile to that in Colombia?
Provide a succinct answer. 0.3. What is the ratio of the Balance of Payment (as % of service exports) in 2005 in Chile to that in Congo (Democratic)?
Provide a short and direct response. 16.67. What is the ratio of the Balance of Payment (as % of service exports) of 2006 in Chile to that in Congo (Democratic)?
Make the answer very short. 21.63. What is the ratio of the Balance of Payment (as % of service exports) in 2007 in Chile to that in Congo (Democratic)?
Offer a very short reply. 92.4. What is the ratio of the Balance of Payment (as % of service exports) of 2008 in Chile to that in Congo (Democratic)?
Your answer should be compact. 182.96. What is the ratio of the Balance of Payment (as % of service exports) of 2005 in Colombia to that in Congo (Democratic)?
Provide a short and direct response. 55.12. What is the ratio of the Balance of Payment (as % of service exports) of 2006 in Colombia to that in Congo (Democratic)?
Offer a very short reply. 71.3. What is the ratio of the Balance of Payment (as % of service exports) of 2007 in Colombia to that in Congo (Democratic)?
Your answer should be compact. 280.97. What is the ratio of the Balance of Payment (as % of service exports) in 2008 in Colombia to that in Congo (Democratic)?
Provide a succinct answer. 605.54. What is the difference between the highest and the second highest Balance of Payment (as % of service exports) of 2005?
Your answer should be very brief. 3.83. What is the difference between the highest and the second highest Balance of Payment (as % of service exports) in 2006?
Your answer should be compact. 2.98. What is the difference between the highest and the second highest Balance of Payment (as % of service exports) in 2007?
Offer a terse response. 6.35. What is the difference between the highest and the second highest Balance of Payment (as % of service exports) of 2008?
Your response must be concise. 3.68. What is the difference between the highest and the lowest Balance of Payment (as % of service exports) in 2005?
Provide a short and direct response. 54.29. What is the difference between the highest and the lowest Balance of Payment (as % of service exports) in 2006?
Your answer should be compact. 53.33. What is the difference between the highest and the lowest Balance of Payment (as % of service exports) of 2007?
Your answer should be very brief. 61.05. What is the difference between the highest and the lowest Balance of Payment (as % of service exports) in 2008?
Offer a very short reply. 57.81. 